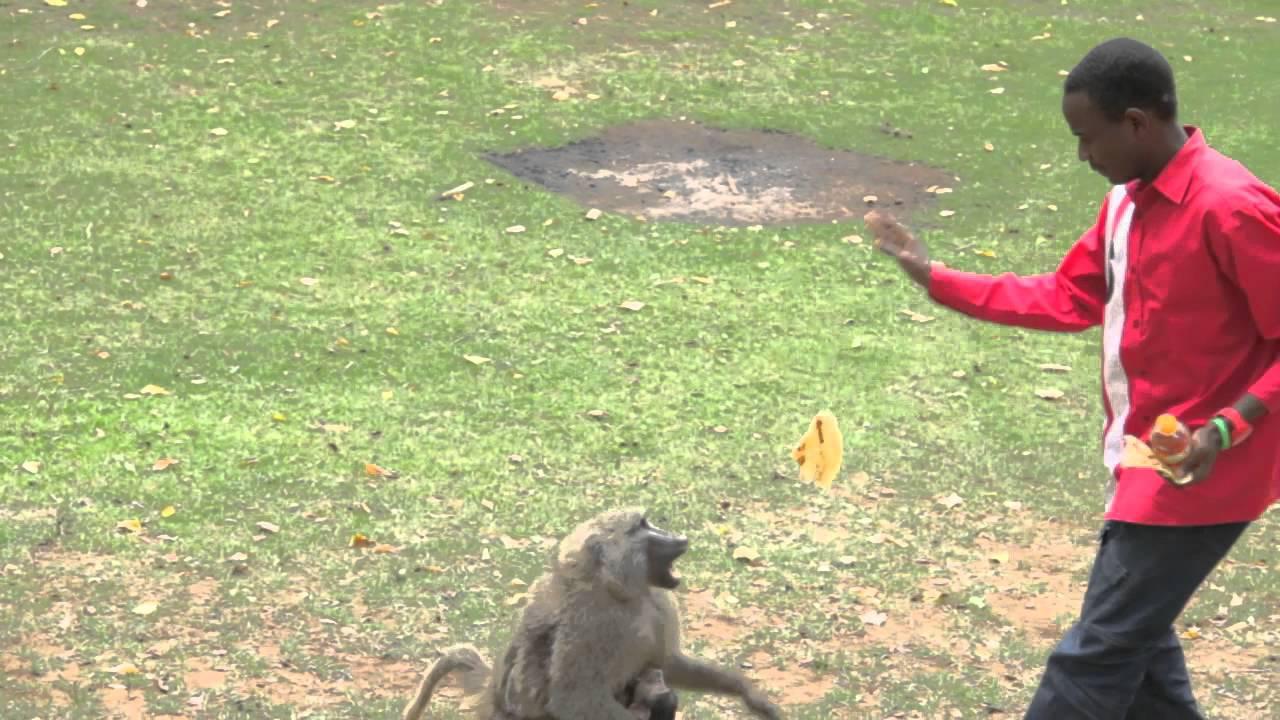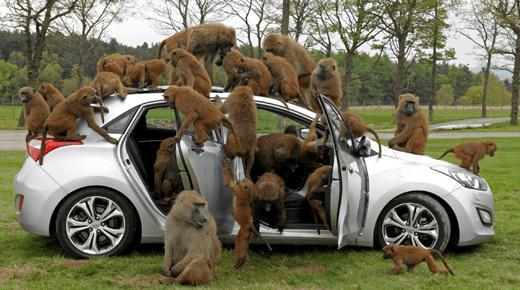The first image is the image on the left, the second image is the image on the right. Analyze the images presented: Is the assertion "There are monkeys on top of a vehicle's roof in at least one of the images." valid? Answer yes or no. Yes. The first image is the image on the left, the second image is the image on the right. Evaluate the accuracy of this statement regarding the images: "The left image contains a woman carrying groceries.". Is it true? Answer yes or no. No. 